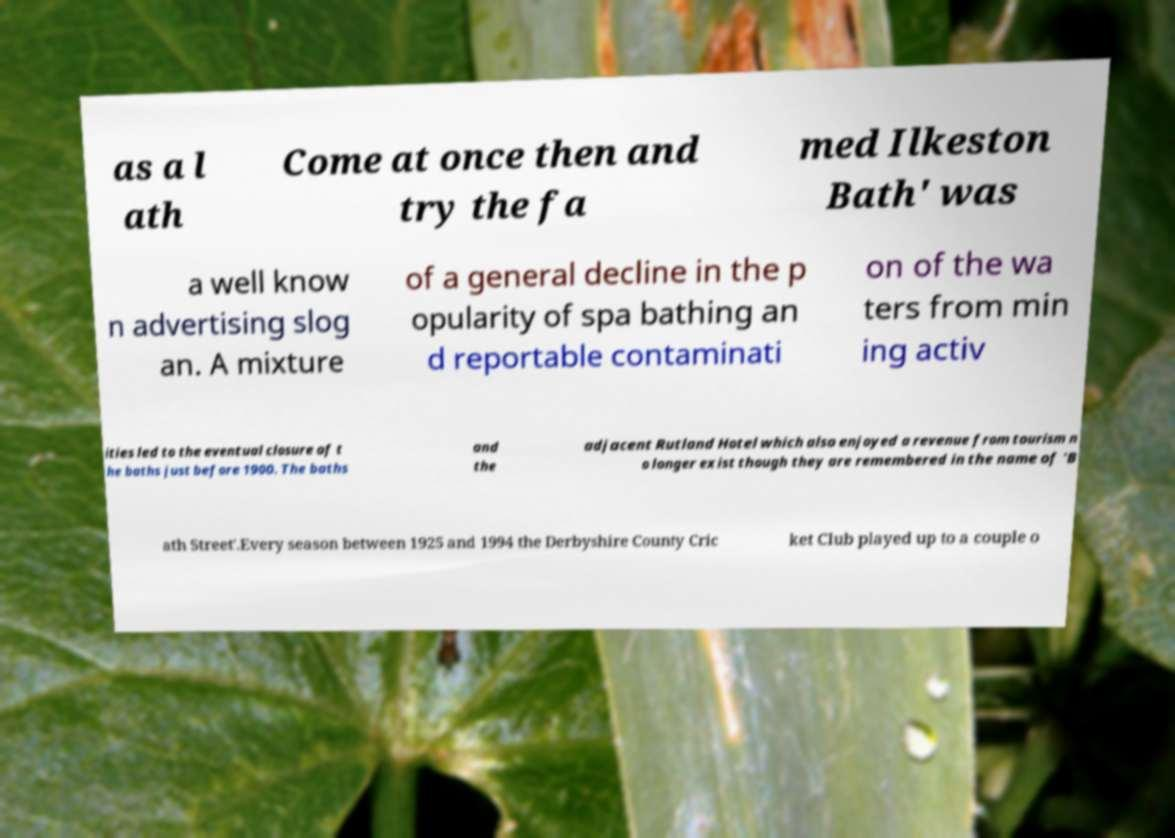For documentation purposes, I need the text within this image transcribed. Could you provide that? as a l ath Come at once then and try the fa med Ilkeston Bath' was a well know n advertising slog an. A mixture of a general decline in the p opularity of spa bathing an d reportable contaminati on of the wa ters from min ing activ ities led to the eventual closure of t he baths just before 1900. The baths and the adjacent Rutland Hotel which also enjoyed a revenue from tourism n o longer exist though they are remembered in the name of 'B ath Street'.Every season between 1925 and 1994 the Derbyshire County Cric ket Club played up to a couple o 